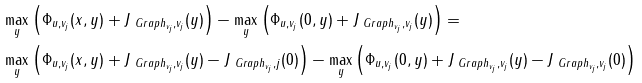Convert formula to latex. <formula><loc_0><loc_0><loc_500><loc_500>& \max _ { y } \left ( \Phi _ { u , v _ { j } } ( x , y ) + J _ { \ G r a p h _ { v _ { j } } , v _ { j } } ( y ) \right ) - \max _ { y } \left ( \Phi _ { u , v _ { j } } ( 0 , y ) + J _ { \ G r a p h _ { v _ { j } } , v _ { j } } ( y ) \right ) = \\ & \max _ { y } \left ( \Phi _ { u , v _ { j } } ( x , y ) + J _ { \ G r a p h _ { v _ { j } } , v _ { j } } ( y ) - J _ { \ G r a p h _ { v _ { j } } , j } ( 0 ) \right ) - \max _ { y } \left ( \Phi _ { u , v _ { j } } ( 0 , y ) + J _ { \ G r a p h _ { v _ { j } } , v _ { j } } ( y ) - J _ { \ G r a p h _ { v _ { j } } , v _ { j } } ( 0 ) \right )</formula> 